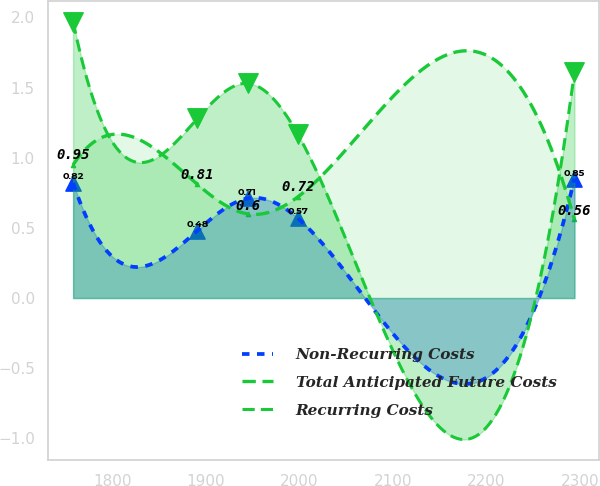Convert chart. <chart><loc_0><loc_0><loc_500><loc_500><line_chart><ecel><fcel>Non-Recurring Costs<fcel>Total Anticipated Future Costs<fcel>Recurring Costs<nl><fcel>1758.1<fcel>0.82<fcel>0.95<fcel>1.97<nl><fcel>1890.98<fcel>0.48<fcel>0.81<fcel>1.28<nl><fcel>1944.59<fcel>0.71<fcel>0.6<fcel>1.53<nl><fcel>1998.19<fcel>0.57<fcel>0.72<fcel>1.17<nl><fcel>2294.15<fcel>0.85<fcel>0.56<fcel>1.61<nl></chart> 